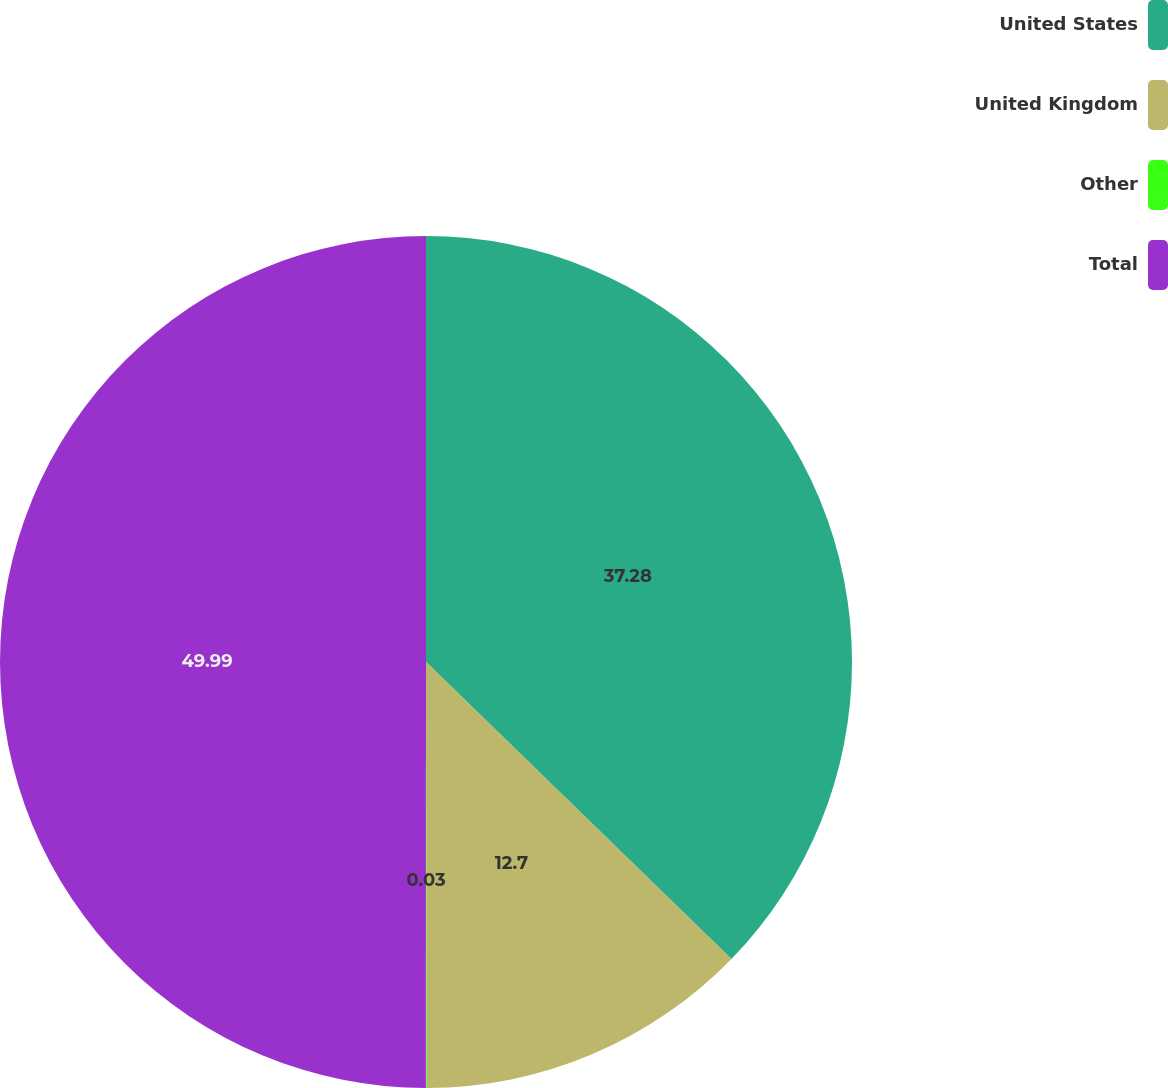Convert chart. <chart><loc_0><loc_0><loc_500><loc_500><pie_chart><fcel>United States<fcel>United Kingdom<fcel>Other<fcel>Total<nl><fcel>37.28%<fcel>12.7%<fcel>0.03%<fcel>50.0%<nl></chart> 